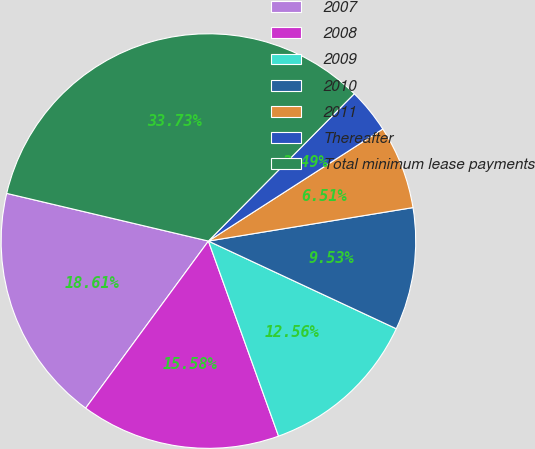Convert chart. <chart><loc_0><loc_0><loc_500><loc_500><pie_chart><fcel>2007<fcel>2008<fcel>2009<fcel>2010<fcel>2011<fcel>Thereafter<fcel>Total minimum lease payments<nl><fcel>18.61%<fcel>15.58%<fcel>12.56%<fcel>9.53%<fcel>6.51%<fcel>3.49%<fcel>33.73%<nl></chart> 